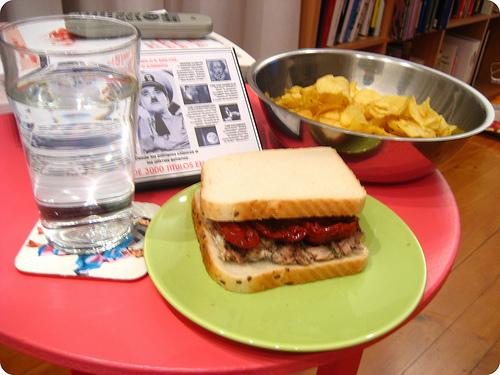What items can be found on the red table? A chicken sandwich with red peppers, a stainless steel bowl of plain potato chips, a tall glass of water on a white coaster, a DVD case with a picture of Charlie Chaplin, and a gray remote control can be found on the red table. Give a brief summary of the entire scene, including the meal and entertainment setup. A red, wooden table on a hardwood floor is holding a meal comprised of a chicken sandwich with red peppers on a green plate, a stainless steel bowl of plain potato chips, and a tall glass of water on a white coaster. Nearby, there is a DVD case with a picture of Charlie Chaplin and a gray remote control for the entertainment setup. The table is near a wooden bookshelf filled with books, and there is a printed picture of Hitler on the shelf next to the entertainment items. Mention something unusual about the image, in terms of historical figures. There is a printed picture of Hitler near the DVD case with a picture of Charlie Chaplin, which is an unusual juxtaposition of historical figures. Provide a brief description of the sandwich on the table. The sandwich has white bread, is filled with chicken, red peppers, and vegetables, and is sitting on a green plate. Name three objects that are on the bookshelf. There is a wooden bookcase containing rows of books, a printed picture of Hitler, and a reflection of the red table on the side of a silver bowl. Describe the style of the table in the image. The table is wooden, painted red, and is situated on a hardwood floor. Which items on the table are part of entertainment setup? A DVD case with a picture of Charlie Chaplin and a gray remote control are part of the entertainment setup. Which entertainment item can be found on the table? A DVD case with a picture of Charlie Chaplin, accompanied by a gray remote control, is on the table. What color is the remote control in the image? The remote control is gray in color. Identify the main components of the meal on the table. There is a chicken sandwich with red peppers on a green plate, a stainless steel bowl of plain potato chips, and a tall glass of water on a white coaster. 